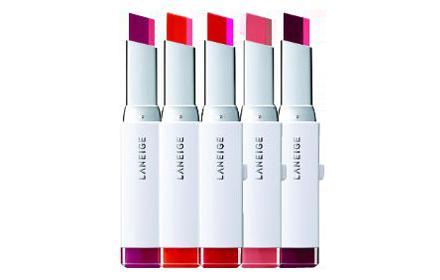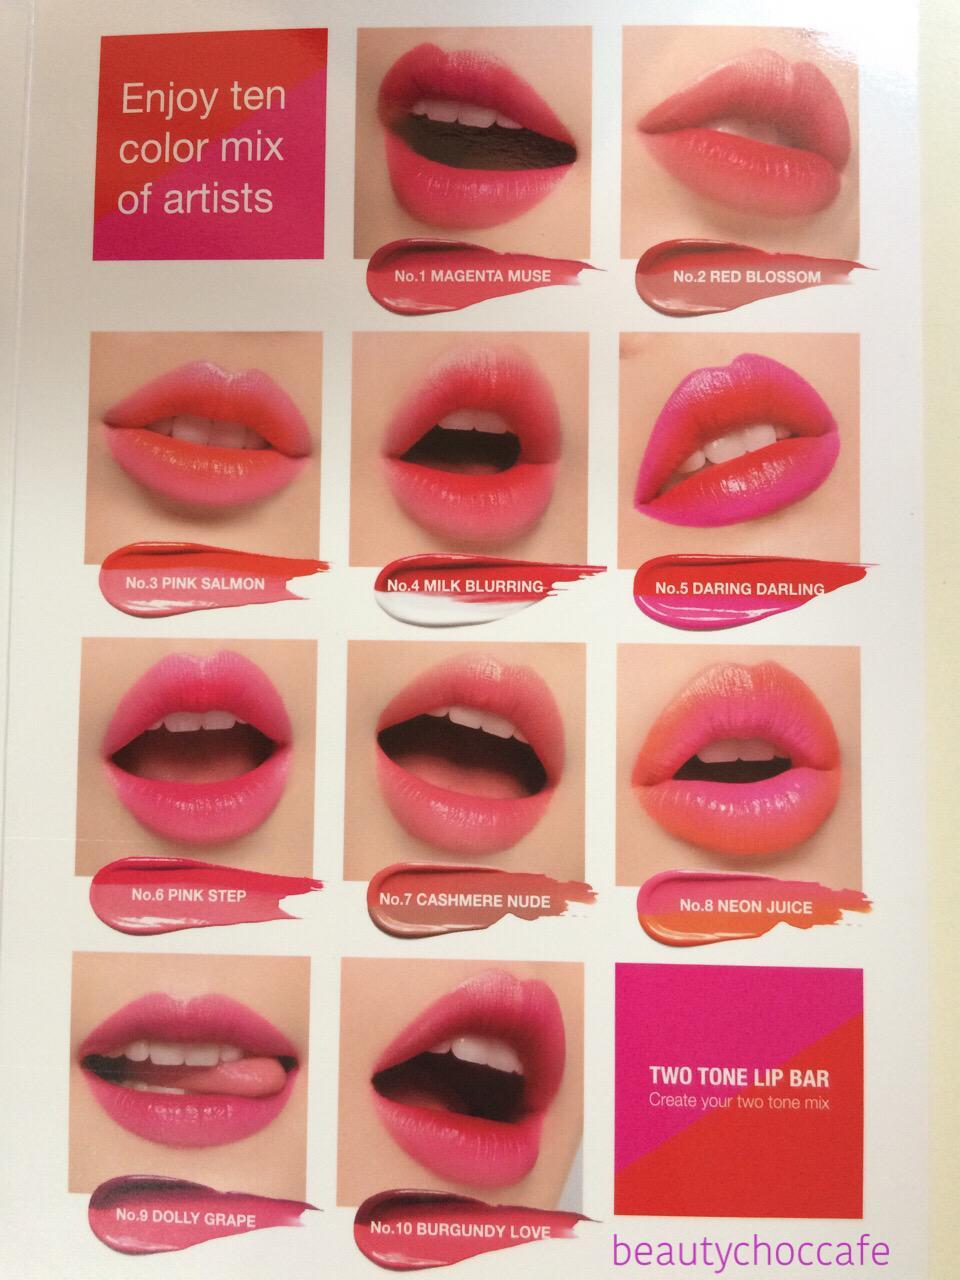The first image is the image on the left, the second image is the image on the right. Assess this claim about the two images: "An image shows a collage of at least ten painted pairs of lips.". Correct or not? Answer yes or no. Yes. The first image is the image on the left, the second image is the image on the right. Given the left and right images, does the statement "One image shows 5 or more tubes of lipstick, and the other shows how the colors look when applied to the lips." hold true? Answer yes or no. Yes. 